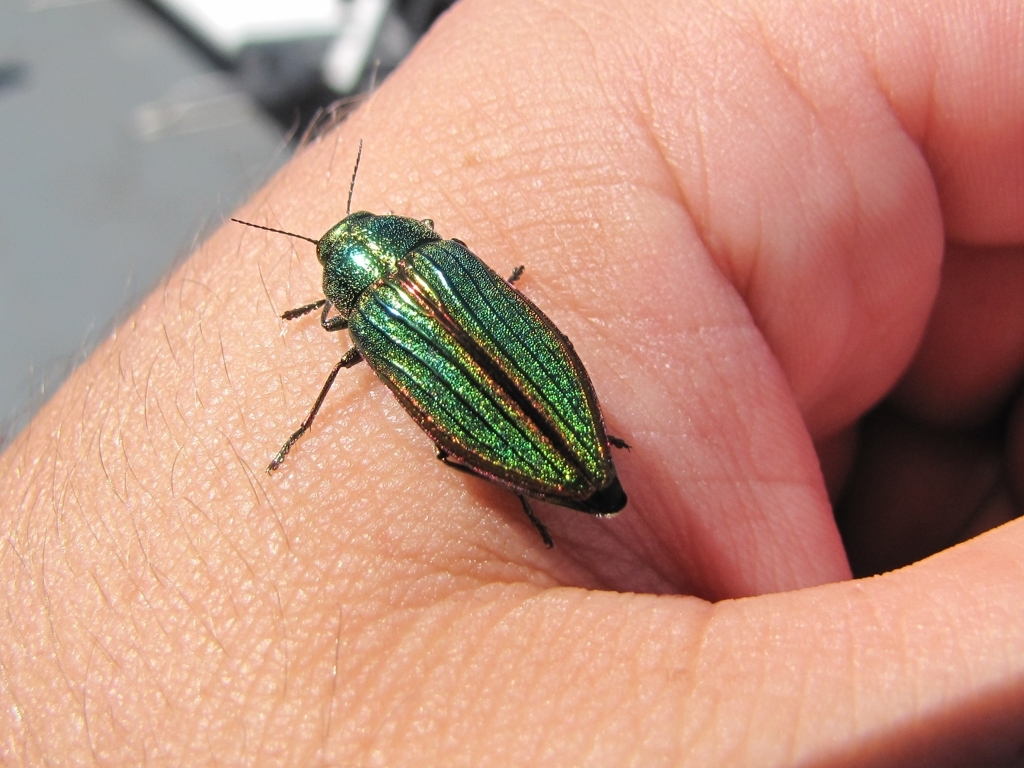This insect's iridescent colors are stunning. What could be the purpose of such a vibrant display? The vibrant iridescence can serve multiple purposes. It may be a form of camouflage, breaking up the insect's outline among leaves and reflections. It can also play a role in thermoregulation, attracting mates, or deterring predators through mimicry or by suggesting toxicity. 